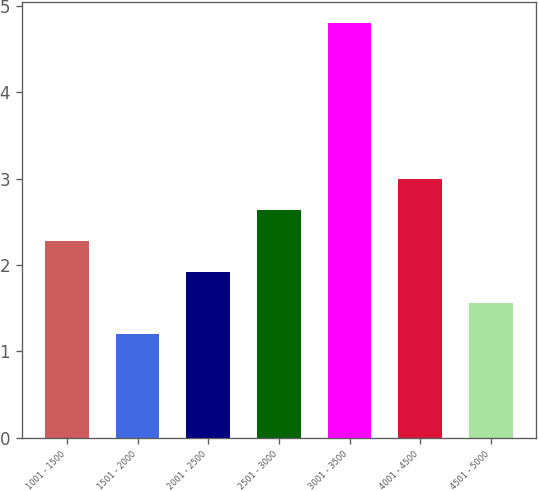Convert chart. <chart><loc_0><loc_0><loc_500><loc_500><bar_chart><fcel>1001 - 1500<fcel>1501 - 2000<fcel>2001 - 2500<fcel>2501 - 3000<fcel>3001 - 3500<fcel>4001 - 4500<fcel>4501 - 5000<nl><fcel>2.28<fcel>1.2<fcel>1.92<fcel>2.64<fcel>4.8<fcel>3<fcel>1.56<nl></chart> 